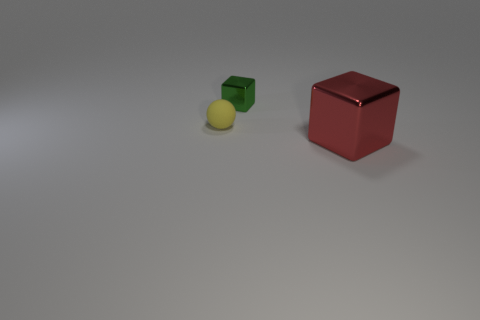What colors are the objects in the image? The objects in the image consist of a green cube, a red cube, and a yellow sphere. 